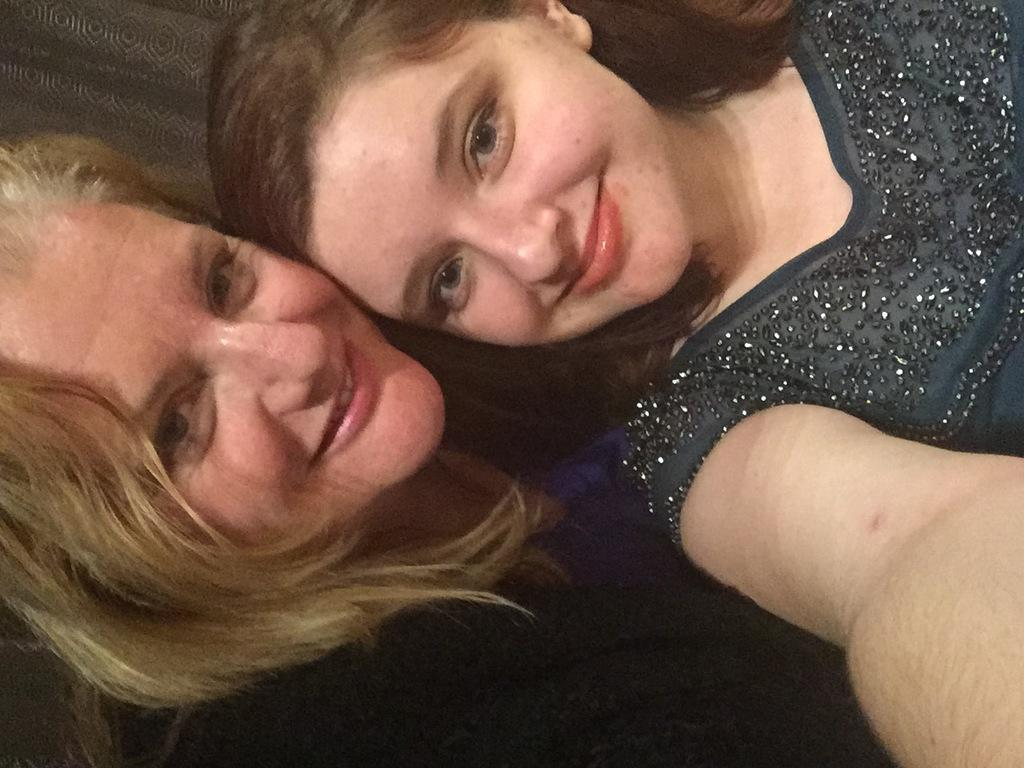How many people are in the picture? There are two women in the picture. What expressions do the women have in the picture? The two women are smiling. What type of floor can be seen beneath the women in the picture? There is no information about the floor in the image, as the focus is on the two women and their expressions. 